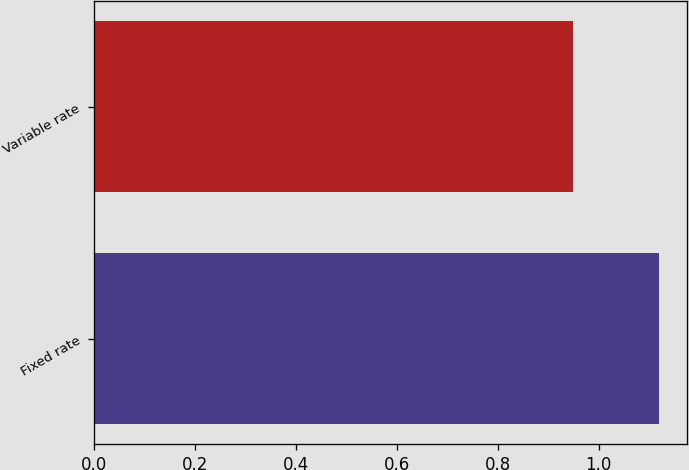Convert chart. <chart><loc_0><loc_0><loc_500><loc_500><bar_chart><fcel>Fixed rate<fcel>Variable rate<nl><fcel>1.12<fcel>0.95<nl></chart> 